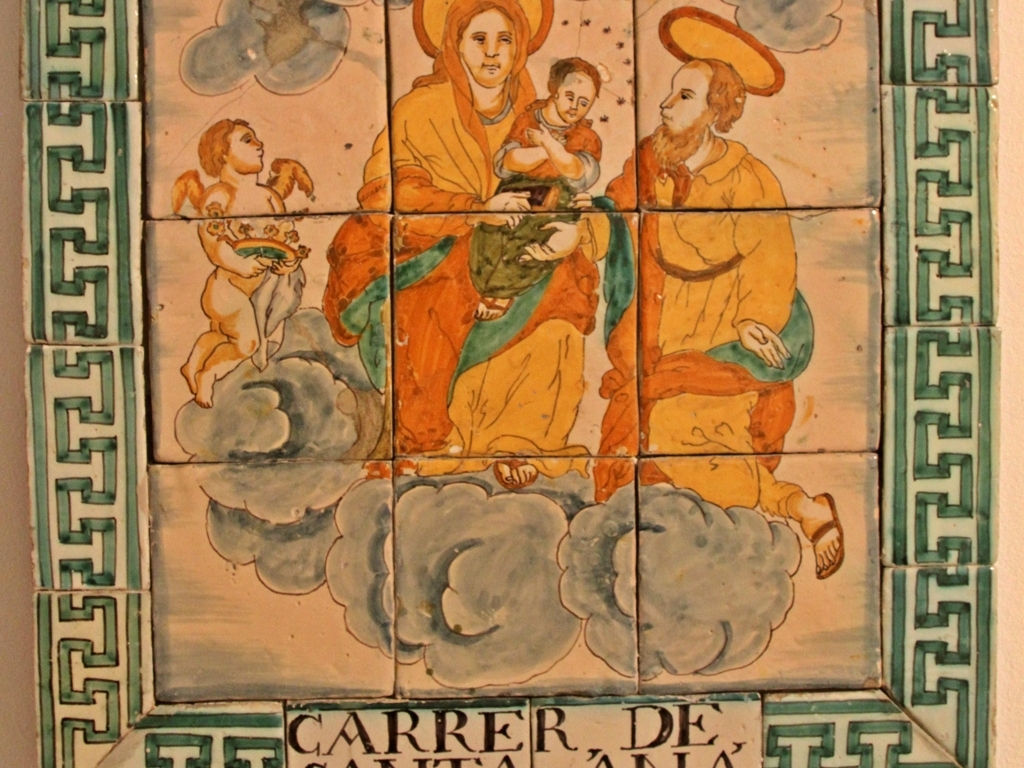Can you tell me what style or period these tiles represent? The tiles appear to be hand-painted ceramics, likely indicative of traditional styles, possibly from the Renaissance or a subsequent period that sought to emulate that era's aesthetic. The imagery and inscriptions suggest a connection to European, perhaps Mediterranean, art traditions. 